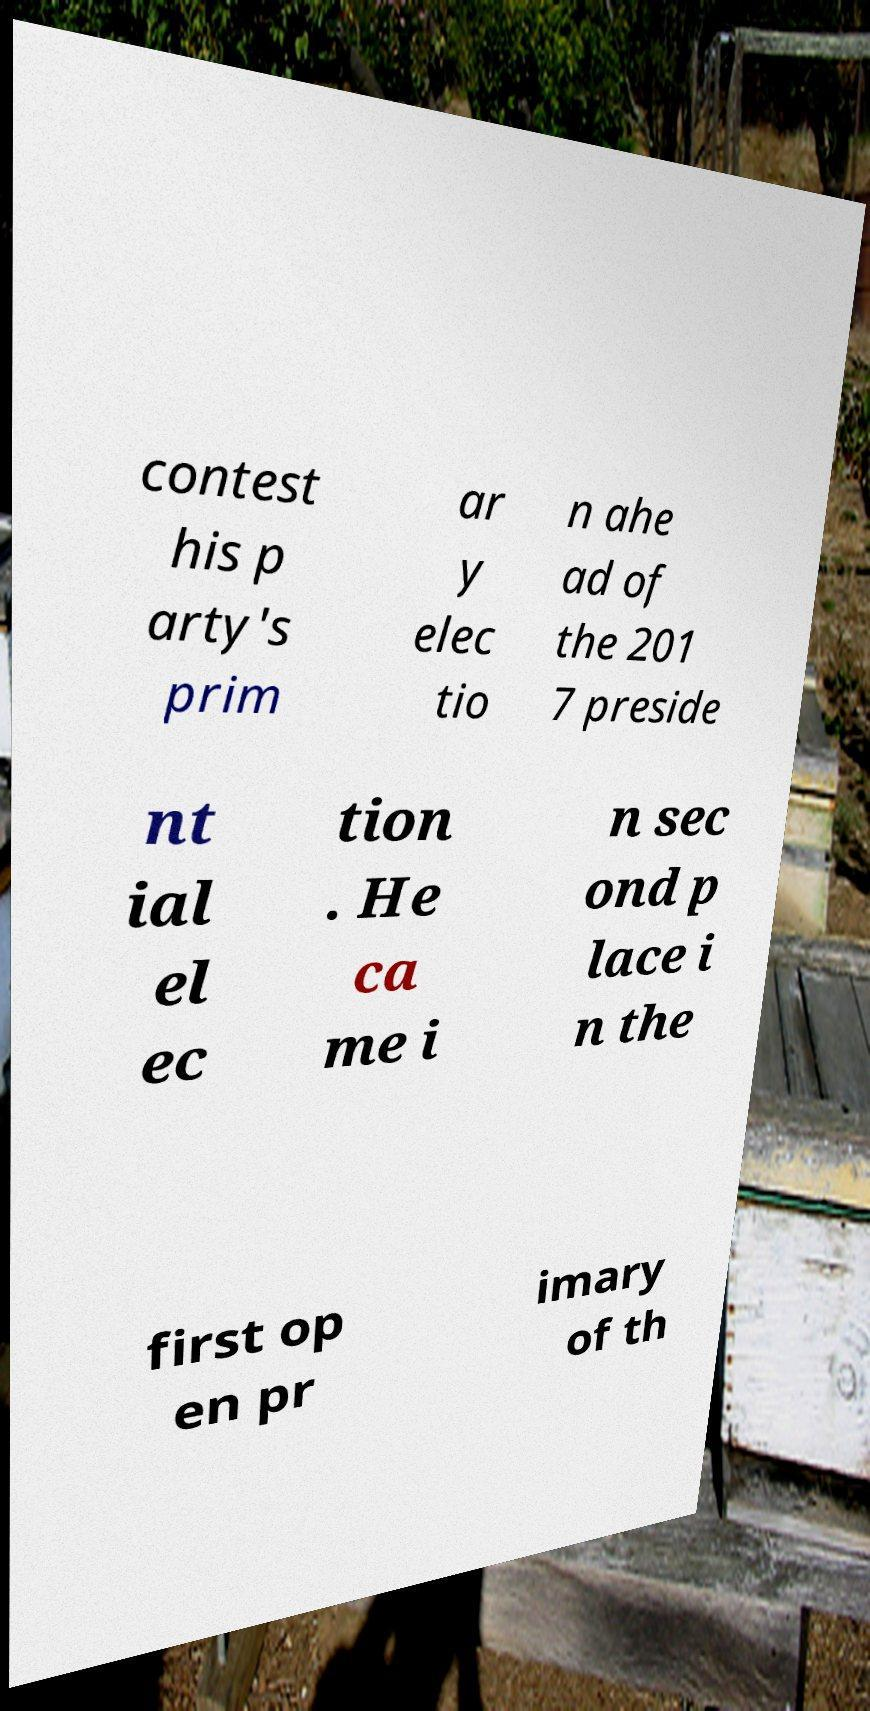Please identify and transcribe the text found in this image. contest his p arty's prim ar y elec tio n ahe ad of the 201 7 preside nt ial el ec tion . He ca me i n sec ond p lace i n the first op en pr imary of th 